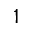<formula> <loc_0><loc_0><loc_500><loc_500>1</formula> 